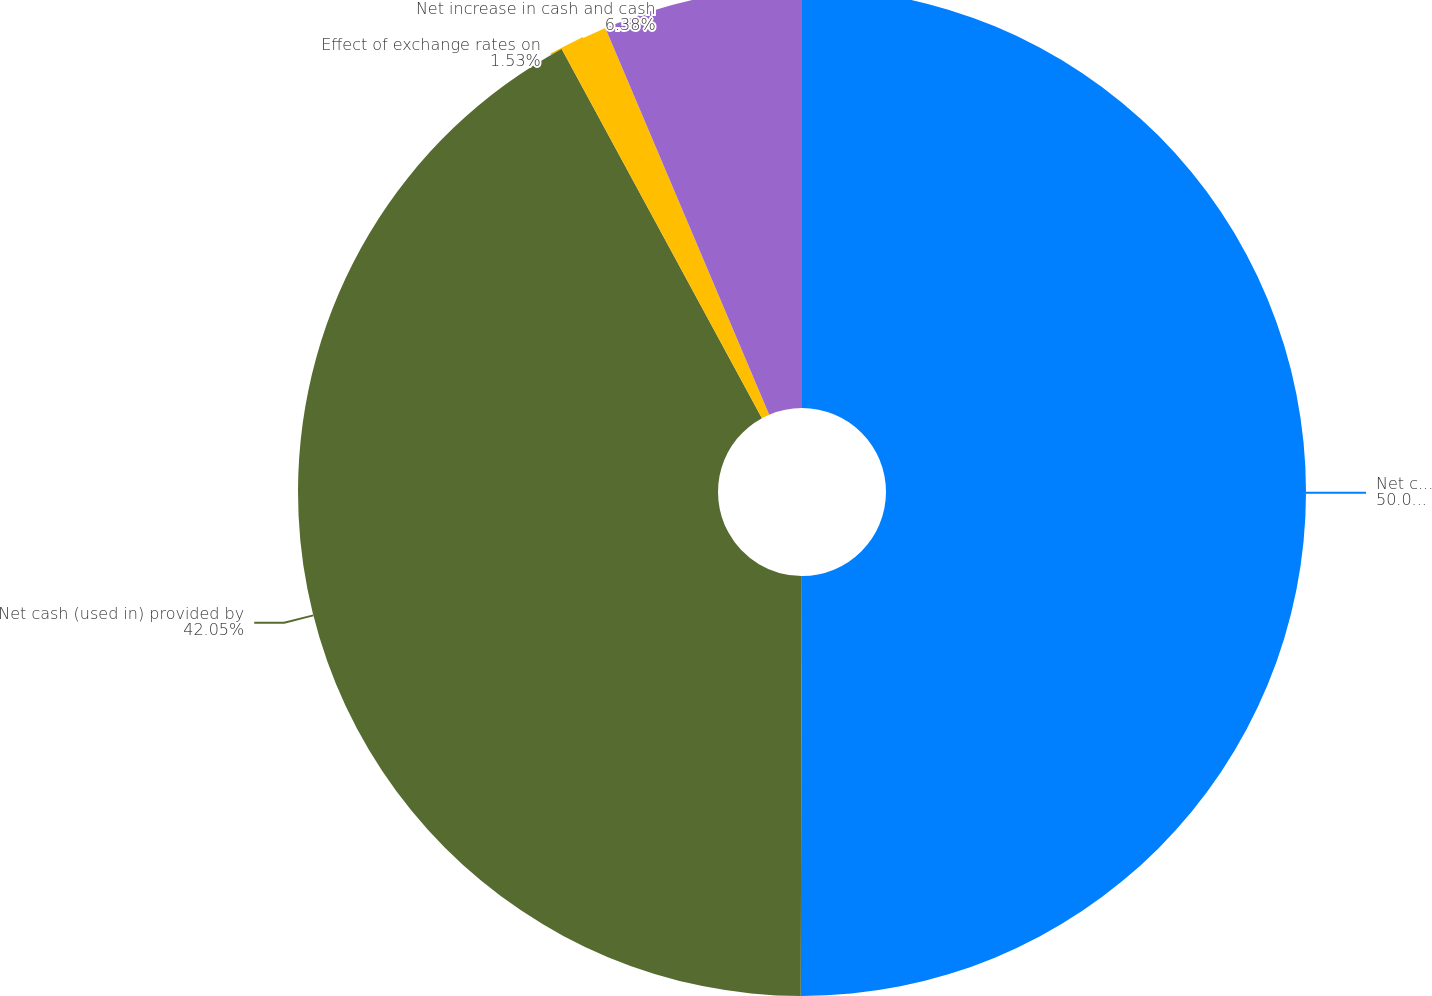Convert chart. <chart><loc_0><loc_0><loc_500><loc_500><pie_chart><fcel>Net cash provided by operating<fcel>Net cash (used in) provided by<fcel>Effect of exchange rates on<fcel>Net increase in cash and cash<nl><fcel>50.04%<fcel>42.05%<fcel>1.53%<fcel>6.38%<nl></chart> 